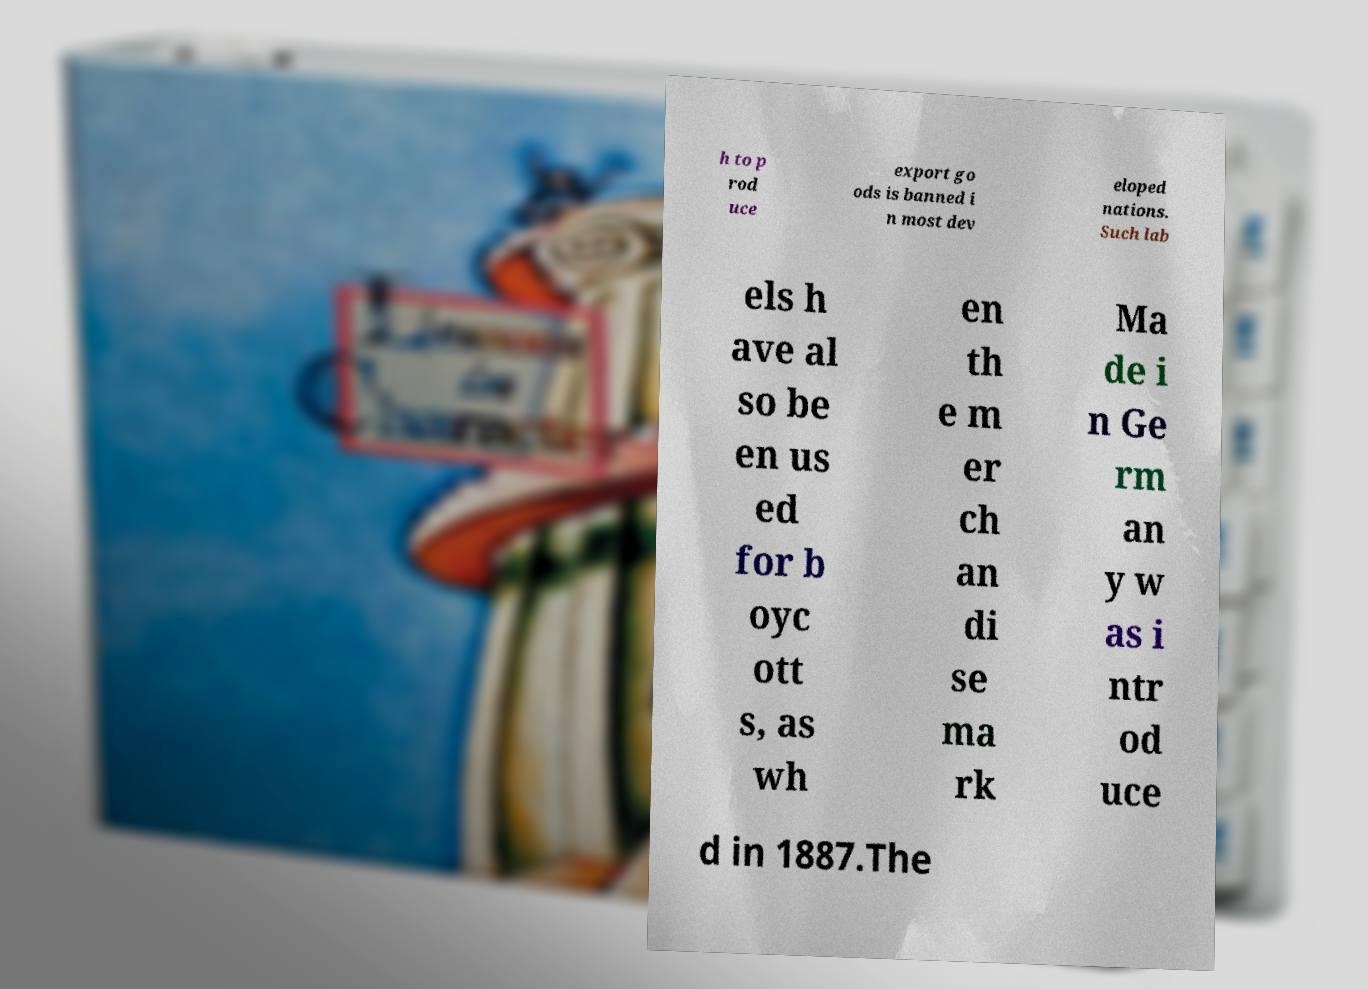Please identify and transcribe the text found in this image. h to p rod uce export go ods is banned i n most dev eloped nations. Such lab els h ave al so be en us ed for b oyc ott s, as wh en th e m er ch an di se ma rk Ma de i n Ge rm an y w as i ntr od uce d in 1887.The 